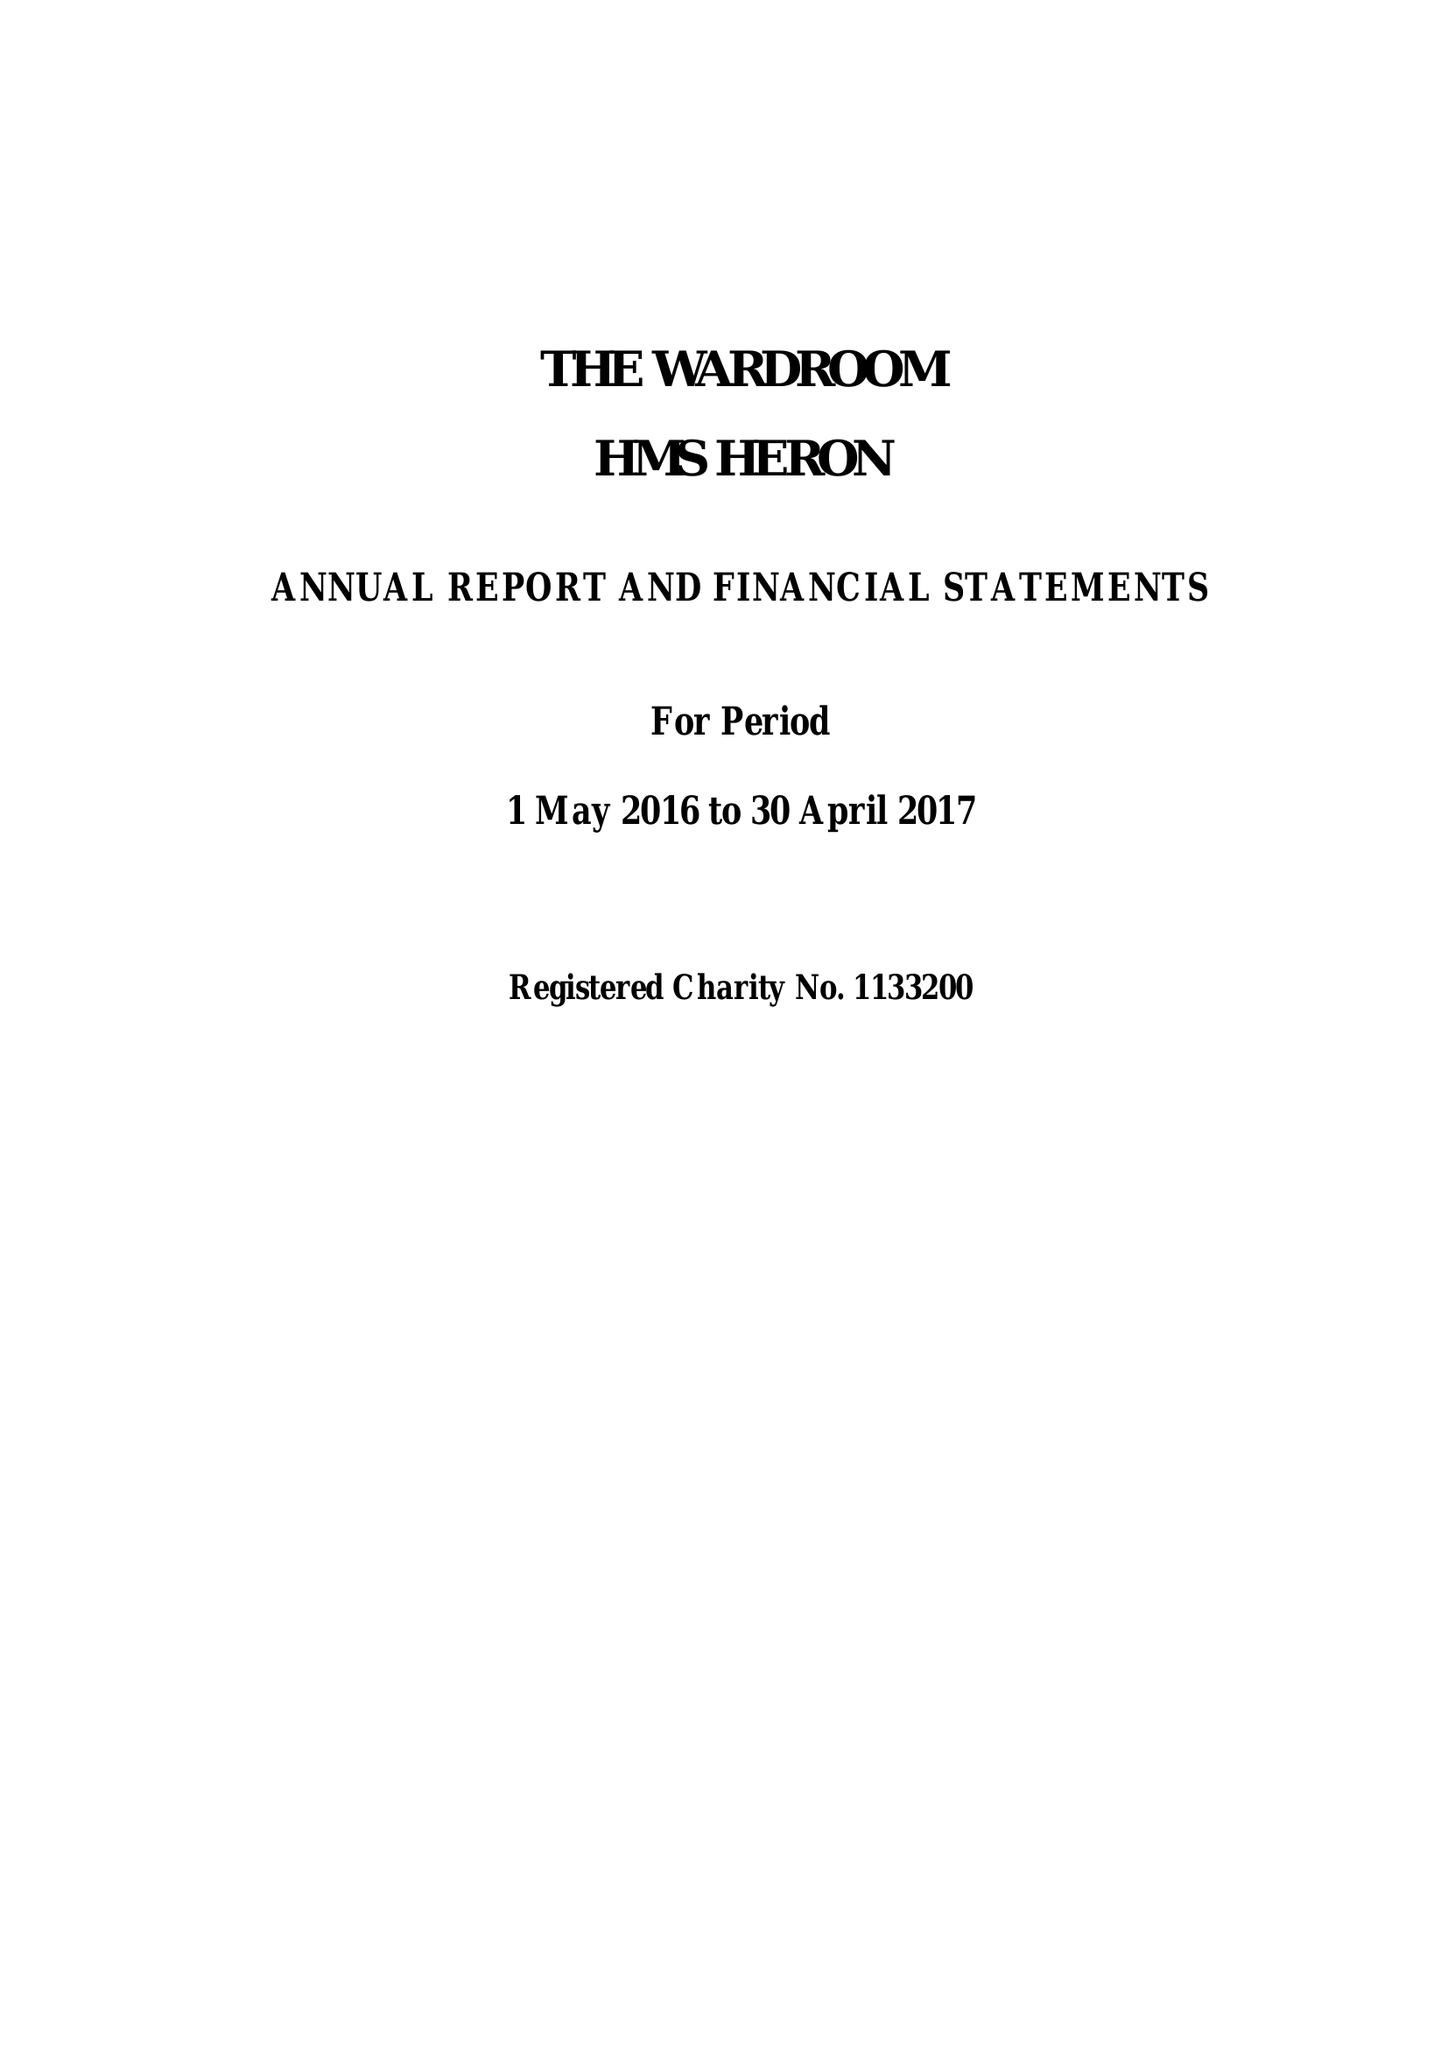What is the value for the income_annually_in_british_pounds?
Answer the question using a single word or phrase. 295967.42 